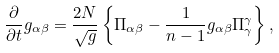Convert formula to latex. <formula><loc_0><loc_0><loc_500><loc_500>\frac { \partial } { \partial t } g _ { \alpha \beta } = \frac { 2 N } { \sqrt { g } } \left \{ \Pi _ { \alpha \beta } - \frac { 1 } { n - 1 } g _ { \alpha \beta } \Pi _ { \gamma } ^ { \gamma } \right \} ,</formula> 